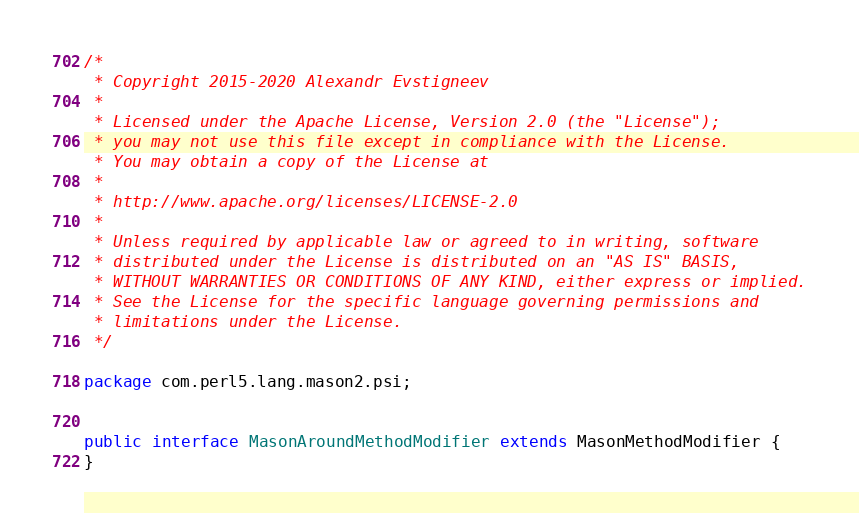<code> <loc_0><loc_0><loc_500><loc_500><_Java_>/*
 * Copyright 2015-2020 Alexandr Evstigneev
 *
 * Licensed under the Apache License, Version 2.0 (the "License");
 * you may not use this file except in compliance with the License.
 * You may obtain a copy of the License at
 *
 * http://www.apache.org/licenses/LICENSE-2.0
 *
 * Unless required by applicable law or agreed to in writing, software
 * distributed under the License is distributed on an "AS IS" BASIS,
 * WITHOUT WARRANTIES OR CONDITIONS OF ANY KIND, either express or implied.
 * See the License for the specific language governing permissions and
 * limitations under the License.
 */

package com.perl5.lang.mason2.psi;


public interface MasonAroundMethodModifier extends MasonMethodModifier {
}
</code> 